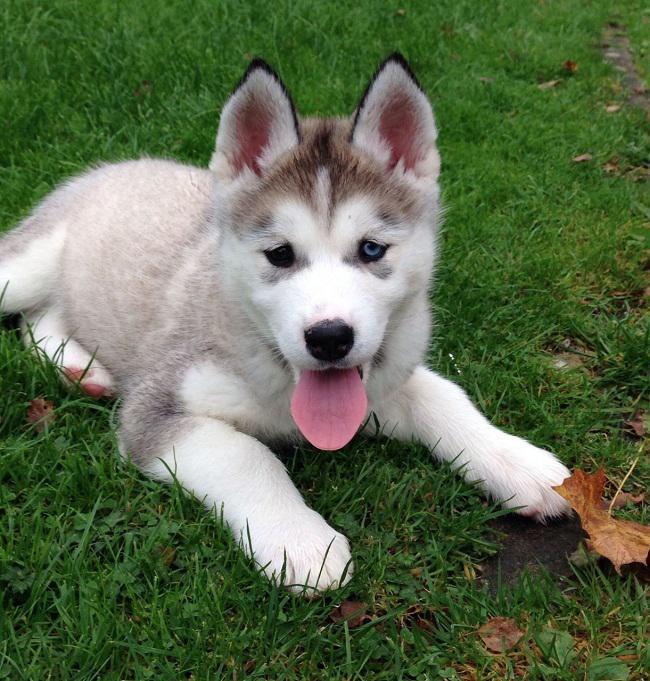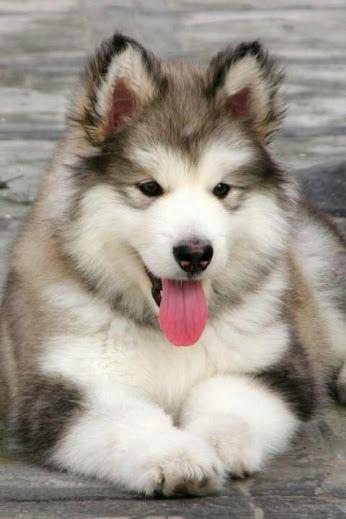The first image is the image on the left, the second image is the image on the right. Considering the images on both sides, is "There are five grey headed husky puppies next to each other." valid? Answer yes or no. No. The first image is the image on the left, the second image is the image on the right. For the images shown, is this caption "One of the images contains two dogs with their mouths open." true? Answer yes or no. No. 